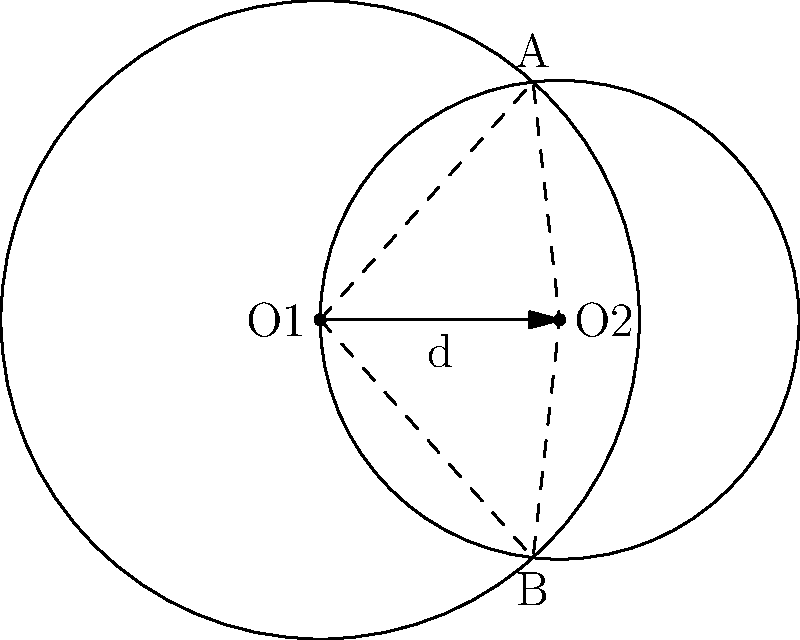In Jimmy Pesto's restaurant, two circular tables overlap as shown in the diagram. Table 1 has a radius of 4 feet, and Table 2 has a radius of 3 feet. The centers of the tables are 3 feet apart. Calculate the area of the overlapping region between the two tables, where the Belcher kids might secretly plan their next fanfiction adventure. Let's approach this step-by-step:

1) First, we need to find the angle $\theta$ at the center of each circle.

2) For Table 1 (radius 4):
   $\cos(\frac{\theta_1}{2}) = \frac{3}{2 \cdot 4} = \frac{3}{8}$
   $\theta_1 = 2 \arccos(\frac{3}{8})$

3) For Table 2 (radius 3):
   $\cos(\frac{\theta_2}{2}) = \frac{3}{2 \cdot 3} = \frac{1}{2}$
   $\theta_2 = 2 \arccos(\frac{1}{2})$

4) The area of a circular sector is given by $\frac{1}{2}r^2\theta$, where $\theta$ is in radians.

5) The area of the triangle formed by the centers and one intersection point is $\frac{1}{2} \cdot 3 \cdot \sqrt{4^2 - (\frac{3}{2})^2} = \frac{3\sqrt{7}}{2}$

6) The area of the overlapping region is the sum of the two sectors minus the two triangles:

   Area = $\frac{1}{2}(4^2 \cdot 2\arccos(\frac{3}{8}) + 3^2 \cdot 2\arccos(\frac{1}{2})) - 2 \cdot \frac{3\sqrt{7}}{2}$

7) Simplifying:
   Area = $8\arccos(\frac{3}{8}) + \frac{9}{2}\arccos(\frac{1}{2}) - 3\sqrt{7}$
Answer: $8\arccos(\frac{3}{8}) + \frac{9}{2}\arccos(\frac{1}{2}) - 3\sqrt{7}$ square feet 